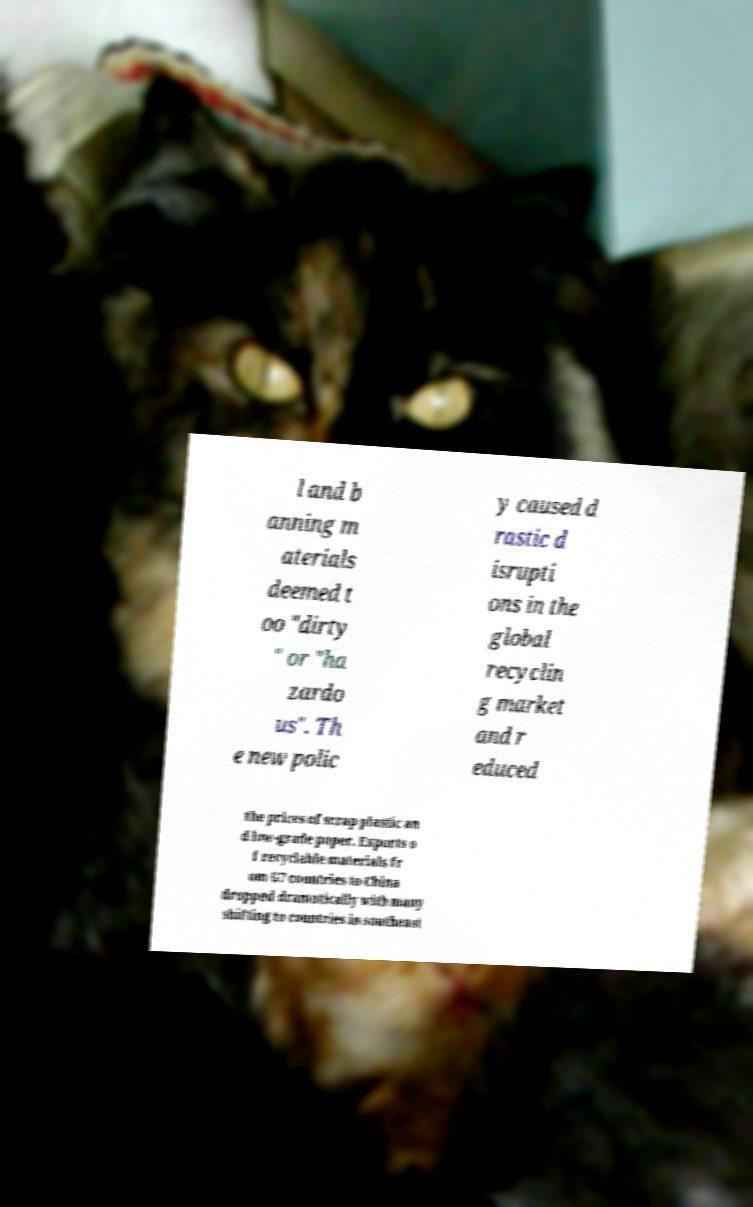Could you assist in decoding the text presented in this image and type it out clearly? l and b anning m aterials deemed t oo "dirty " or "ha zardo us". Th e new polic y caused d rastic d isrupti ons in the global recyclin g market and r educed the prices of scrap plastic an d low-grade paper. Exports o f recyclable materials fr om G7 countries to China dropped dramatically with many shifting to countries in southeast 